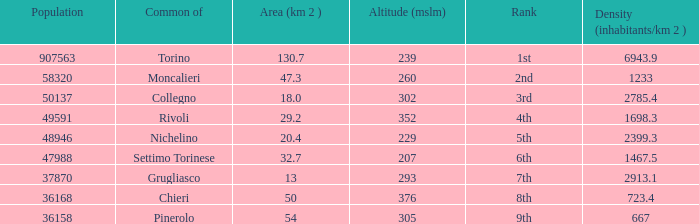What is the density of the common with an area of 20.4 km^2? 2399.3. 